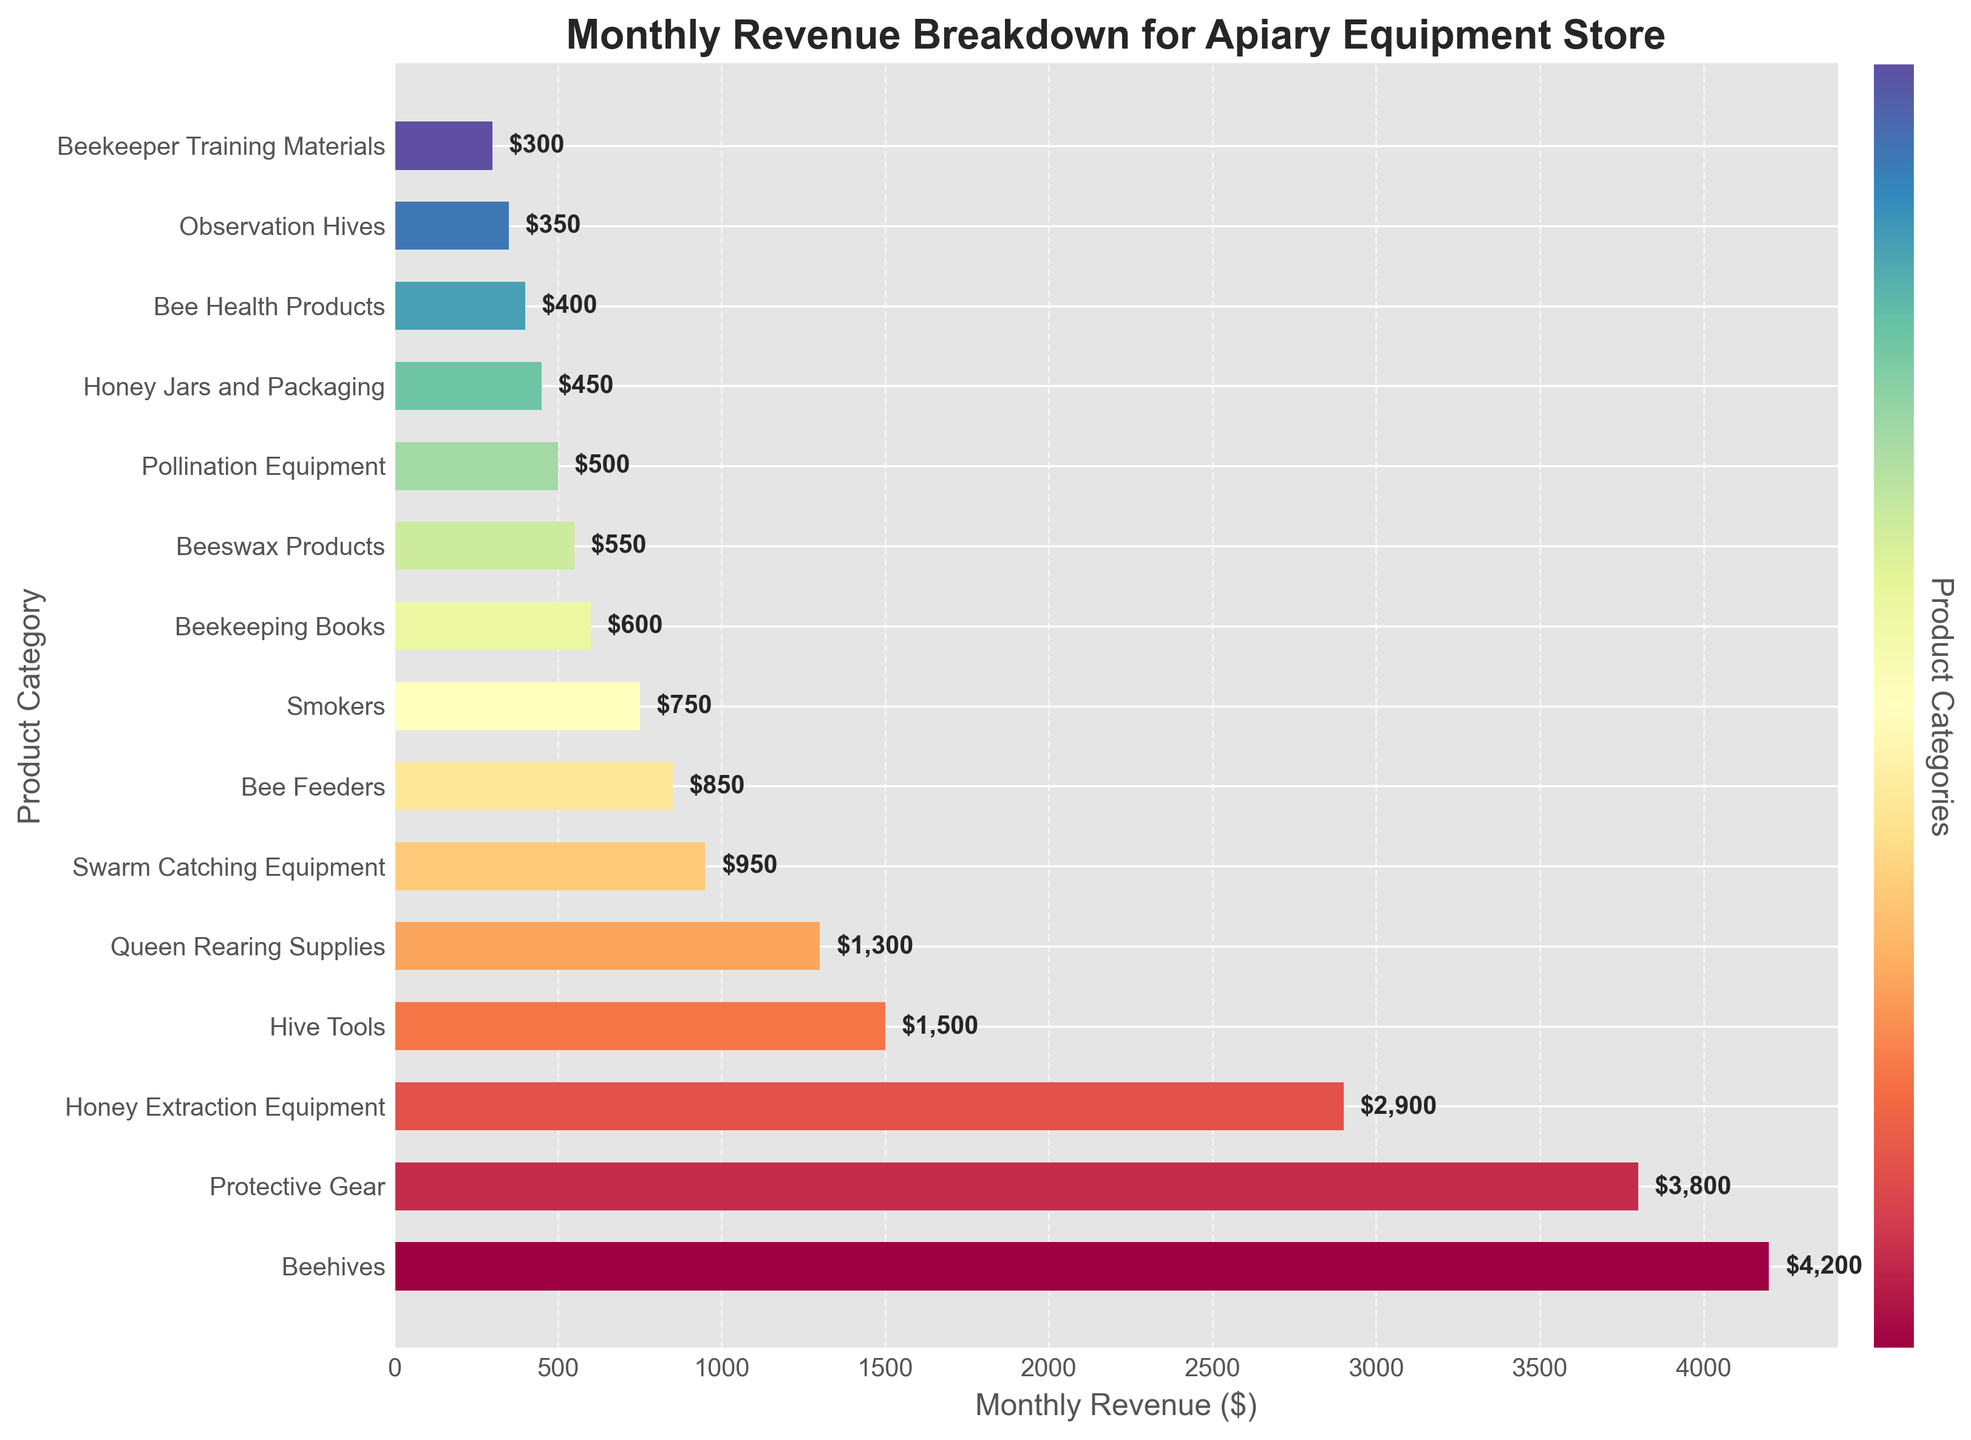Which product category generates the highest revenue? By looking at the figure, identify the longest bar, which corresponds to the highest revenue.
Answer: Beehives What is the total monthly revenue for Queen Rearing Supplies, Swarm Catching Equipment, and Beekeeping Books? First, find the revenue for each category from the visual labels: $1300 for Queen Rearing Supplies, $950 for Swarm Catching Equipment, and $600 for Beekeeping Books. Then, sum them up: 1300 + 950 + 600 = 2850.
Answer: $2850 How much more revenue does Protective Gear generate compared to Swarm Catching Equipment? Find the revenue for Protective Gear ($3800) and Swarm Catching Equipment ($950), then subtract the lesser from the greater: 3800 - 950 = 2850.
Answer: $2850 What percentage of the total monthly revenue is generated by Beehives? Calculate the total revenue by summing all the categories' revenues, then find the revenue for Beehives and compute its percentage. Total revenue = 21,600, Beehives revenue = 4200. Percentage = (4200 / 21600) * 100 ≈ 19.44%.
Answer: ≈ 19.44% Do Bee Feeders generate more revenue than Bee Health Products? Compare the bar lengths of Bee Feeders ($850) and Bee Health Products ($400) to see that Bee Feeders generate more revenue.
Answer: Yes Which two product categories have the smallest revenues, and what are their values? Identify the two shortest bars in the figure, which correspond to Observation Hives ($350) and Beekeeper Training Materials ($300).
Answer: Observation Hives ($350) and Beekeeper Training Materials ($300) What is the average monthly revenue for the Hive Tools, Queen Rearing Supplies, and Honey Extraction Equipment categories? Find the revenues for the three categories: Hive Tools ($1500), Queen Rearing Supplies ($1300), and Honey Extraction Equipment ($2900). Sum them up: 1500 + 1300 + 2900 = 5700, then divide by 3: 5700 / 3 = 1900.
Answer: $1900 If Protective Gear's revenue increased by 10%, what would the new revenue be? Calculate the increased amount by taking 10% of $3800, which is 3800 * 0.10 = 380. Add this to the original revenue: 3800 + 380 = 4180.
Answer: $4180 Which product category's bar is about half the length of the Beehives category's bar? Identify the approximate length of Beehives' bar ($4200) and look for a bar around half this length (~$2100). Swarm Catching Equipment ($950) and Bee Feeders ($850) appear to match this criterion, but Swarm Catching Equipment is closest.
Answer: Swarm Catching Equipment 